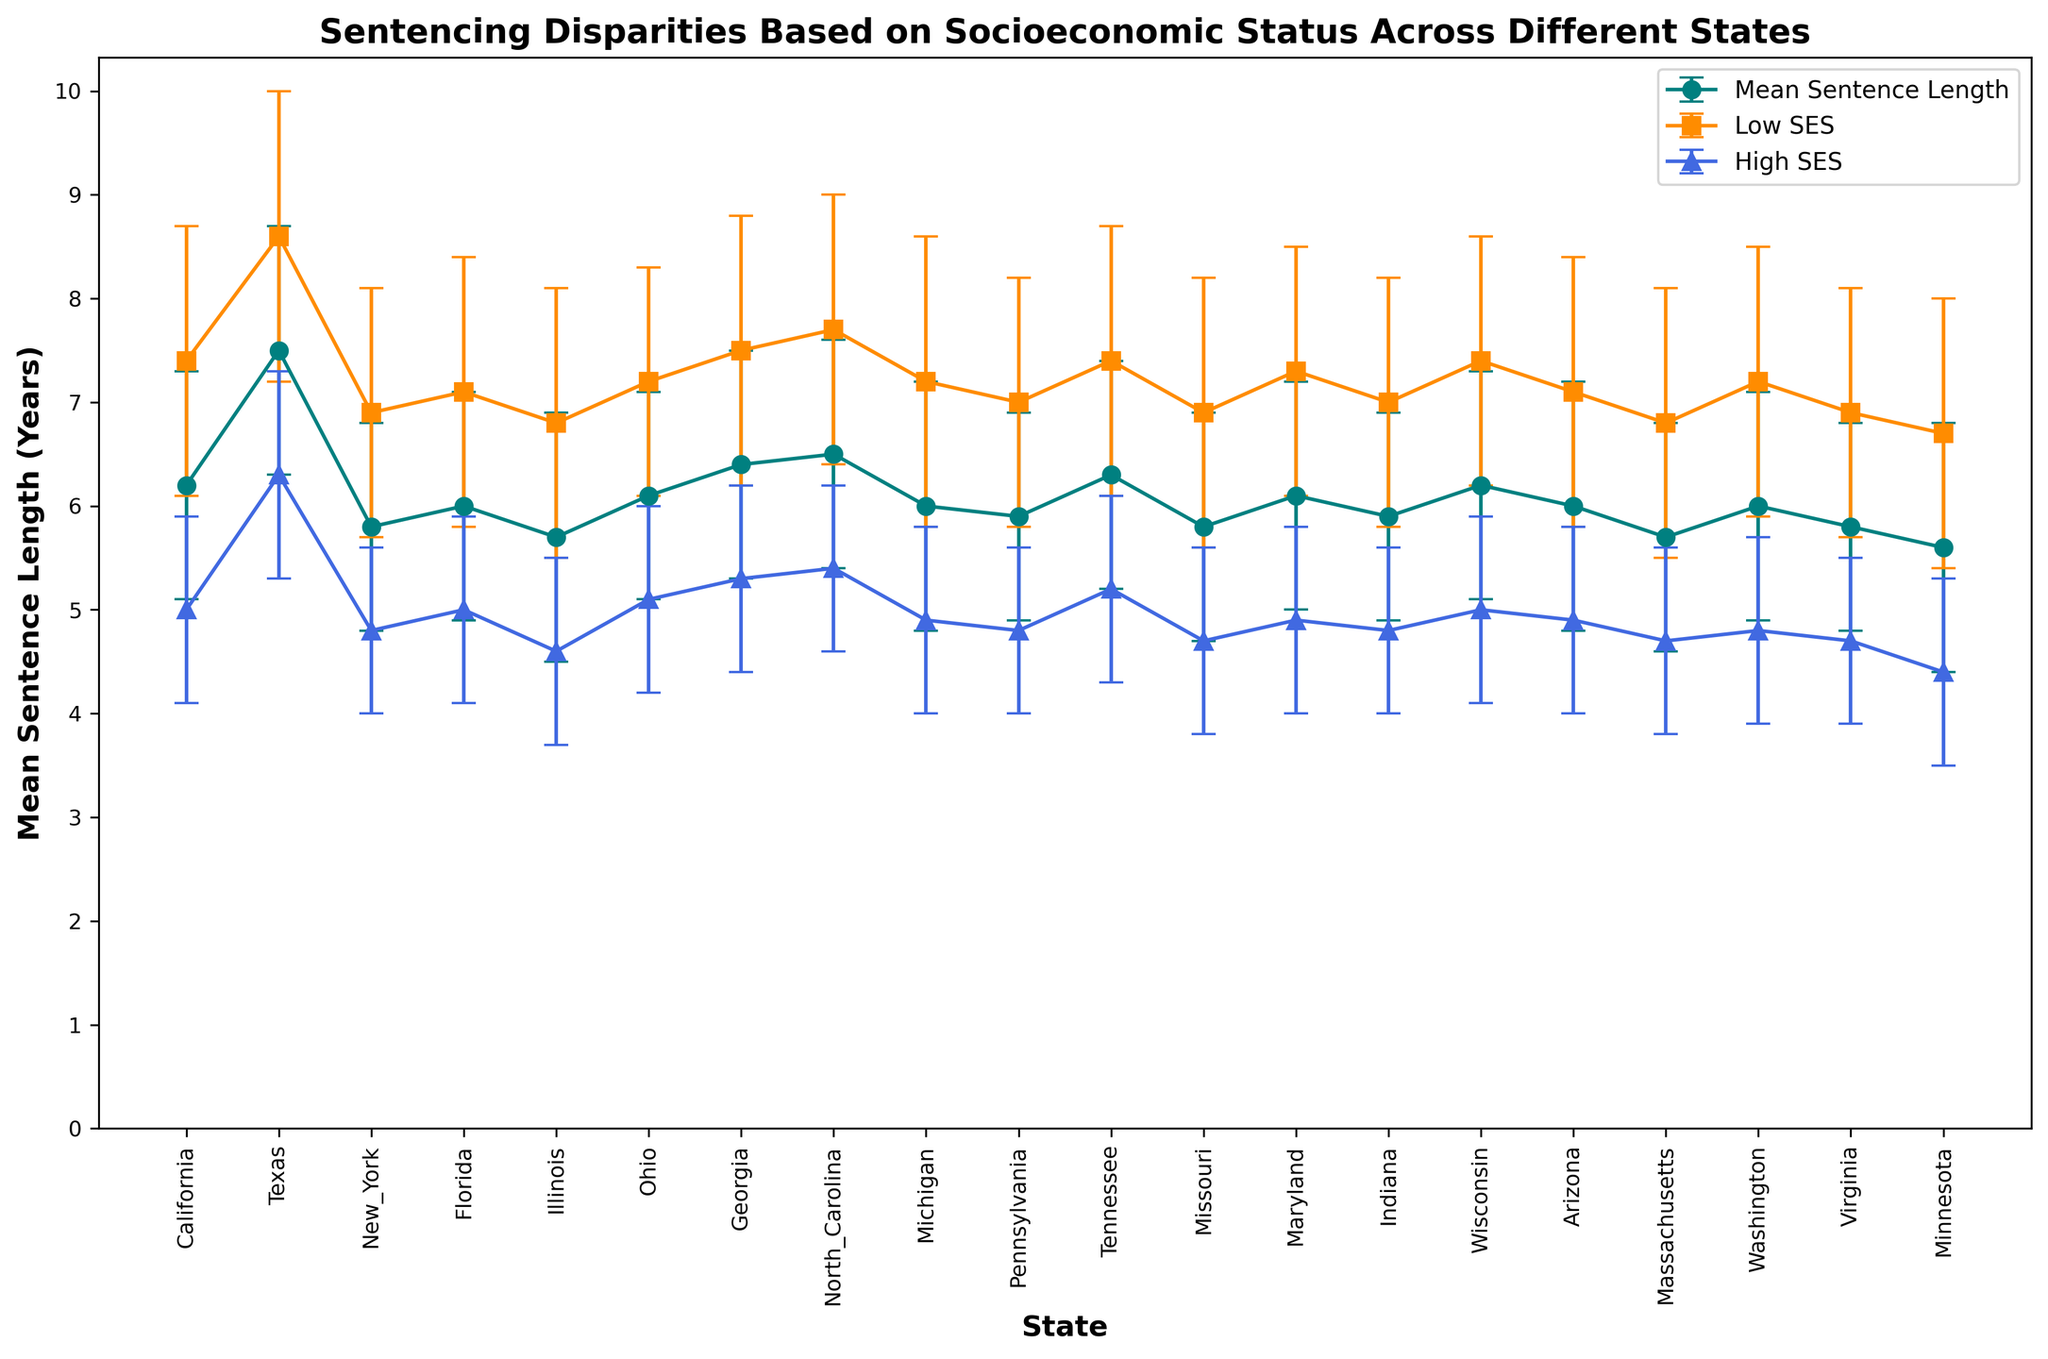What is the overall trend in mean sentence lengths across different states? By examining the plot, we can notice that the mean sentence lengths across different states mostly hover around 6 to 7 years, indicating minor variability between states.
Answer: Around 6 to 7 years Which state has the highest mean sentence length? From the plot, it is evident that Texas has the highest mean sentence length, as indicated by the peak on the Mean Sentence Length curve.
Answer: Texas How does the mean sentence length for low SES compare to high SES in California? In California, the mean sentence length for low SES is 7.4 years, while for high SES it is 5.0 years. This can be seen by comparing the respective points on the Low SES and High SES curves.
Answer: Low SES is higher What is the difference between the mean sentence length of low SES and high SES in Texas? To find the difference, we subtract the mean sentence length of high SES (6.3 years) from that of low SES (8.6 years), which results in a difference of 2.3 years.
Answer: 2.3 years Which state shows the smallest disparity in sentencing between low and high SES groups? By comparing the length of the error bars and the distances between the Low SES and High SES curves, Minnesota shows the smallest disparity with a difference of 2.3 years (6.7 - 4.4).
Answer: Minnesota Between Florida and Ohio, which state exhibits greater variability in sentencing among the low SES group? By comparing the error bars for the Low SES group, Florida and Ohio both have standard deviations of 1.3 years for low SES sentencing, making their variabilities equal.
Answer: Equal What is the general pattern observed in sentencing disparities between low SES and high SES across different states? The general pattern observed is that low SES individuals tend to receive longer sentences compared to high SES individuals across nearly all states.
Answer: Low SES receive longer sentences Which state exhibits the narrowest error bar for the mean sentence length of high SES individuals? By observing the error bars, North Carolina has the narrowest error bar for high SES with a standard deviation of 0.8 years.
Answer: North Carolina Could you list states where the mean sentence lengths between low SES and high SES are more than 2 years apart? By comparing the distances between the Low SES and High SES curves for each state, Texas (2.3 years), Ohio (2.1 years), and Michigan (2.3 years) show sentence lengths differences of more than 2 years apart.
Answer: Texas, Ohio, Michigan What does the height difference between the Low SES and High SES curves suggest in terms of sentencing bias? The height difference indicates a bias where low SES individuals are generally subjected to longer sentences compared to high SES individuals across the board.
Answer: Bias toward longer sentences for low SES 